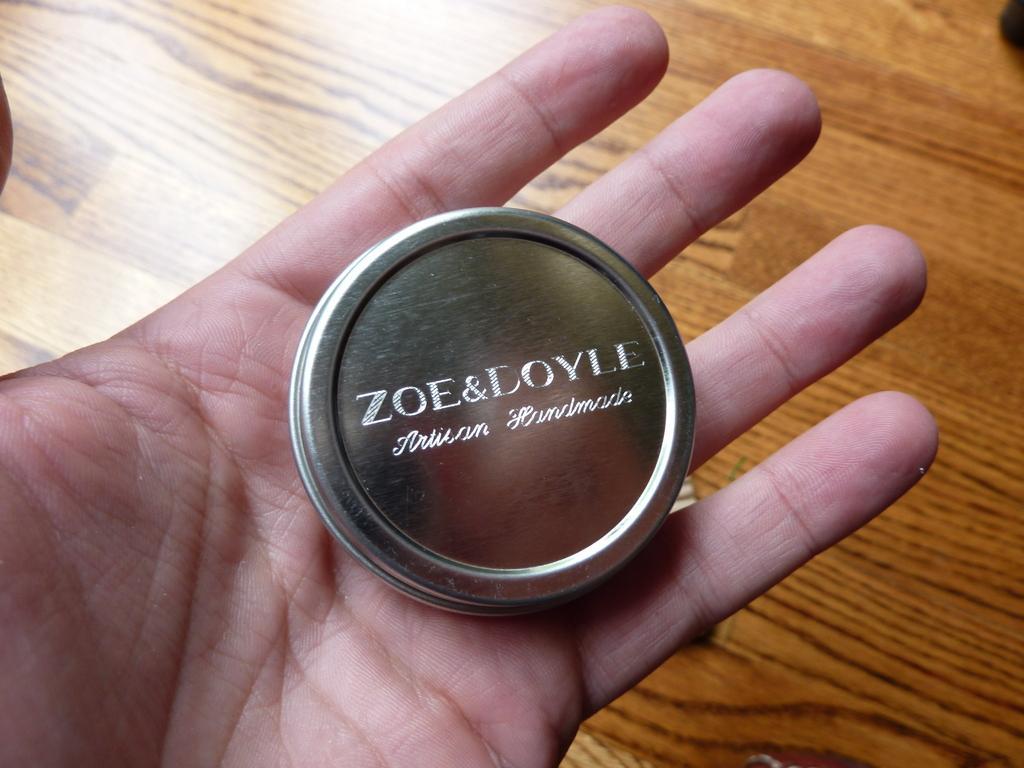Can you describe this image briefly? Person hand with box. This is wooden floor. 